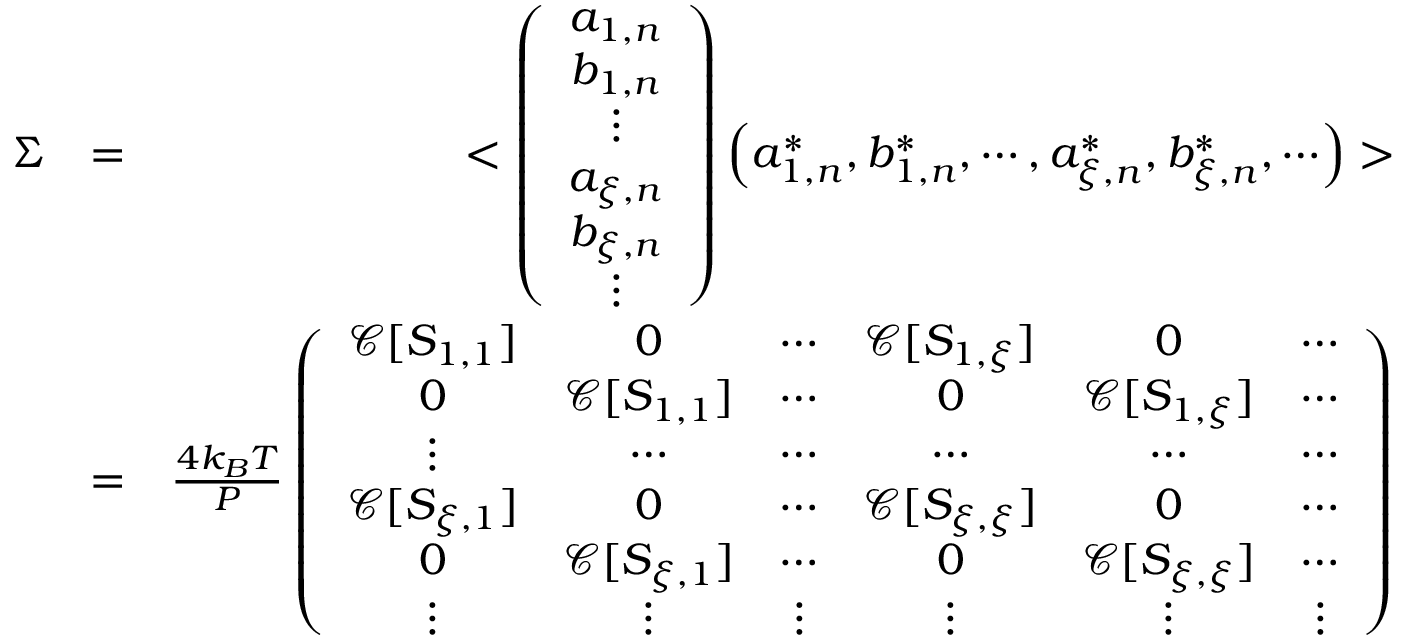<formula> <loc_0><loc_0><loc_500><loc_500>\begin{array} { r l r } { \Sigma } & { = } & { < \left ( \begin{array} { c } { a _ { 1 , n } } \\ { b _ { 1 , n } } \\ { \vdots } \\ { a _ { \xi , n } } \\ { b _ { \xi , n } } \\ { \vdots } \end{array} \right ) \left ( a _ { 1 , n } ^ { * } , b _ { 1 , n } ^ { * } , \cdots , a _ { \xi , n } ^ { * } , b _ { \xi , n } ^ { * } , \cdots \right ) > } \\ & { = } & { \frac { 4 k _ { B } T } { P } \left ( \begin{array} { c c c c c c } { \ m a t h s c r { C } [ S _ { 1 , 1 } ] } & { 0 } & { \cdots } & { \ m a t h s c r { C } [ S _ { 1 , \xi } ] } & { 0 } & { \cdots } \\ { 0 } & { \ m a t h s c r { C } [ S _ { 1 , 1 } ] } & { \cdots } & { 0 } & { \ m a t h s c r { C } [ S _ { 1 , \xi } ] } & { \cdots } \\ { \vdots } & { \cdots } & { \cdots } & { \cdots } & { \cdots } & { \cdots } \\ { \ m a t h s c r { C } [ S _ { \xi , 1 } ] } & { 0 } & { \cdots } & { \ m a t h s c r { C } [ S _ { \xi , \xi } ] } & { 0 } & { \cdots } \\ { 0 } & { \ m a t h s c r { C } [ S _ { \xi , 1 } ] } & { \cdots } & { 0 } & { \ m a t h s c r { C } [ S _ { \xi , \xi } ] } & { \cdots } \\ { \vdots } & { \vdots } & { \vdots } & { \vdots } & { \vdots } & { \vdots } \end{array} \right ) } \end{array}</formula> 